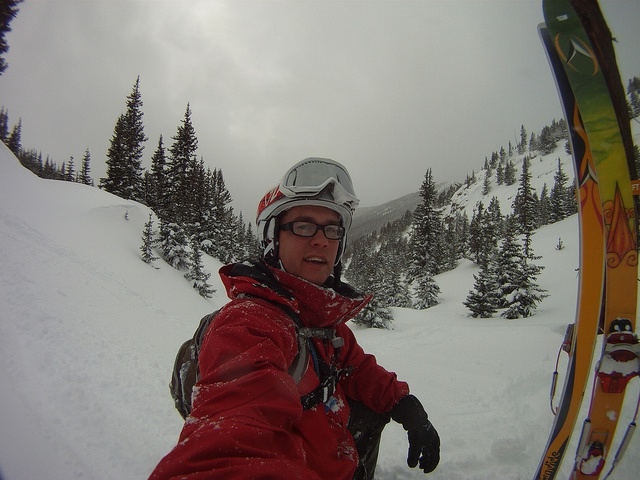Describe the objects in this image and their specific colors. I can see people in black, maroon, gray, and darkgray tones, skis in black, olive, maroon, and gray tones, and backpack in black, maroon, and gray tones in this image. 